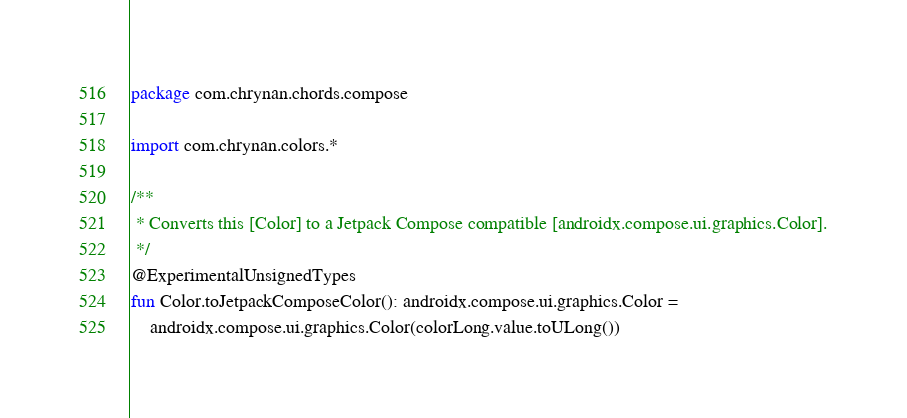<code> <loc_0><loc_0><loc_500><loc_500><_Kotlin_>package com.chrynan.chords.compose

import com.chrynan.colors.*

/**
 * Converts this [Color] to a Jetpack Compose compatible [androidx.compose.ui.graphics.Color].
 */
@ExperimentalUnsignedTypes
fun Color.toJetpackComposeColor(): androidx.compose.ui.graphics.Color =
    androidx.compose.ui.graphics.Color(colorLong.value.toULong())
</code> 